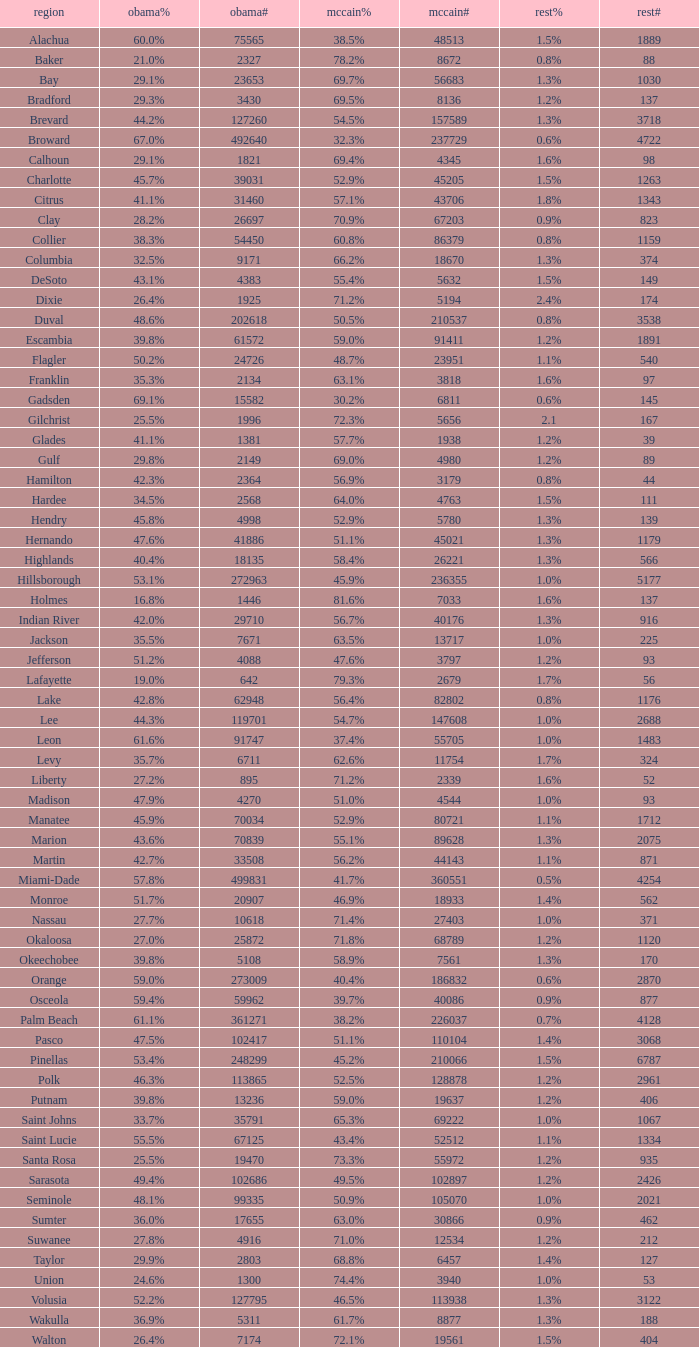What were the number of voters McCain had when Obama had 895? 2339.0. 